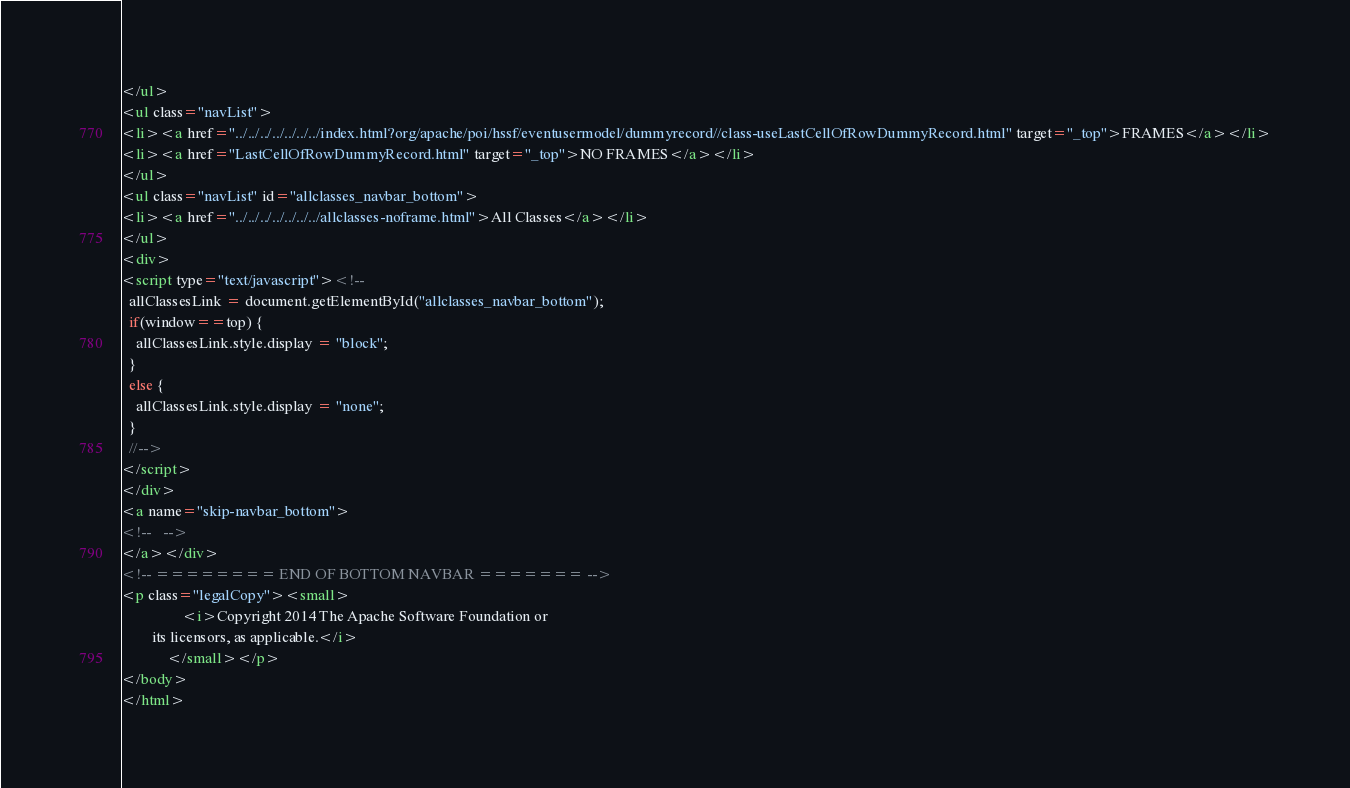Convert code to text. <code><loc_0><loc_0><loc_500><loc_500><_HTML_></ul>
<ul class="navList">
<li><a href="../../../../../../../index.html?org/apache/poi/hssf/eventusermodel/dummyrecord//class-useLastCellOfRowDummyRecord.html" target="_top">FRAMES</a></li>
<li><a href="LastCellOfRowDummyRecord.html" target="_top">NO FRAMES</a></li>
</ul>
<ul class="navList" id="allclasses_navbar_bottom">
<li><a href="../../../../../../../allclasses-noframe.html">All Classes</a></li>
</ul>
<div>
<script type="text/javascript"><!--
  allClassesLink = document.getElementById("allclasses_navbar_bottom");
  if(window==top) {
    allClassesLink.style.display = "block";
  }
  else {
    allClassesLink.style.display = "none";
  }
  //-->
</script>
</div>
<a name="skip-navbar_bottom">
<!--   -->
</a></div>
<!-- ======== END OF BOTTOM NAVBAR ======= -->
<p class="legalCopy"><small>
                <i>Copyright 2014 The Apache Software Foundation or
        its licensors, as applicable.</i>
            </small></p>
</body>
</html>
</code> 